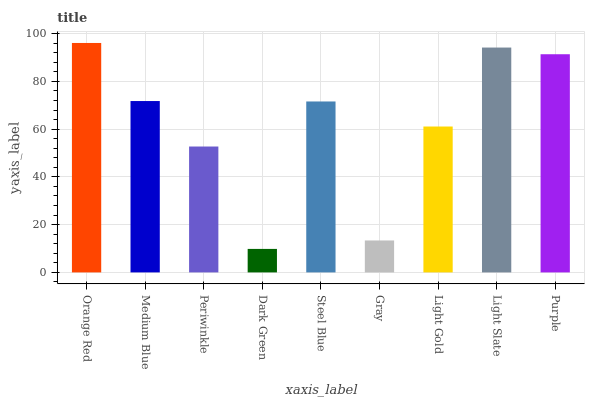Is Dark Green the minimum?
Answer yes or no. Yes. Is Orange Red the maximum?
Answer yes or no. Yes. Is Medium Blue the minimum?
Answer yes or no. No. Is Medium Blue the maximum?
Answer yes or no. No. Is Orange Red greater than Medium Blue?
Answer yes or no. Yes. Is Medium Blue less than Orange Red?
Answer yes or no. Yes. Is Medium Blue greater than Orange Red?
Answer yes or no. No. Is Orange Red less than Medium Blue?
Answer yes or no. No. Is Steel Blue the high median?
Answer yes or no. Yes. Is Steel Blue the low median?
Answer yes or no. Yes. Is Orange Red the high median?
Answer yes or no. No. Is Medium Blue the low median?
Answer yes or no. No. 